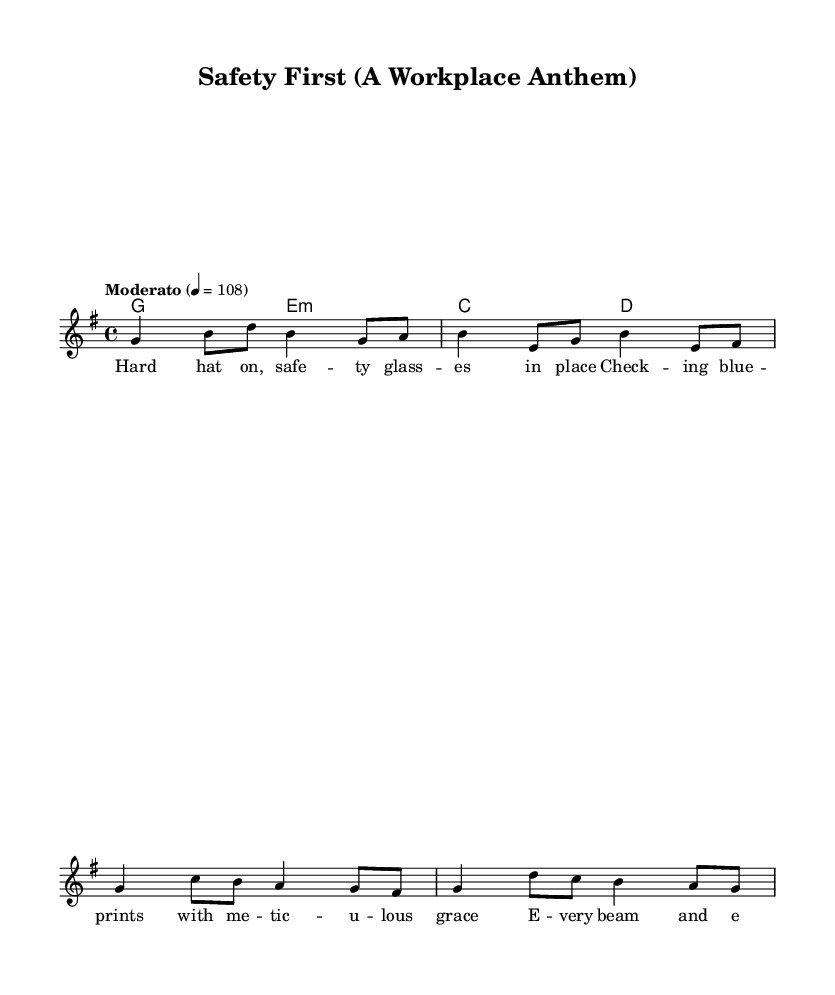What is the key signature of this music? The key signature is G major, which has one sharp (F#). This can be determined by looking at the key signature indicated at the beginning of the staff.
Answer: G major What is the time signature of this music? The time signature is 4/4, visible at the beginning of the score in the time signature indicators. This means there are four beats per measure and the quarter note gets one beat.
Answer: 4/4 What tempo marking is indicated in the music? The tempo marking is "Moderato," which describes the speed of the piece. This can be found written at the beginning of the score above the staff.
Answer: Moderato How many measures are there in the melody? The melody consists of four measures, which can be counted by observing the number of bar lines separating the notes in the staff.
Answer: 4 What is the first lyric line of the verse? The first lyric line is "Hard hat on, safety glasses in place." This can be seen directly beneath the melody notes corresponding to the first phrase.
Answer: Hard hat on, safety glasses in place What is the chord used in the first measure? The chord used in the first measure is G major, as indicated by the chord names above the melody. The G major chord consists of the notes G, B, and D.
Answer: G major What is the last lyric line in the verse? The last lyric line is "Gotta make sure they don't fall." This can be identified by looking at the lyrics written beneath the final melody notes in the last measure of the verse.
Answer: Gotta make sure they don't fall 